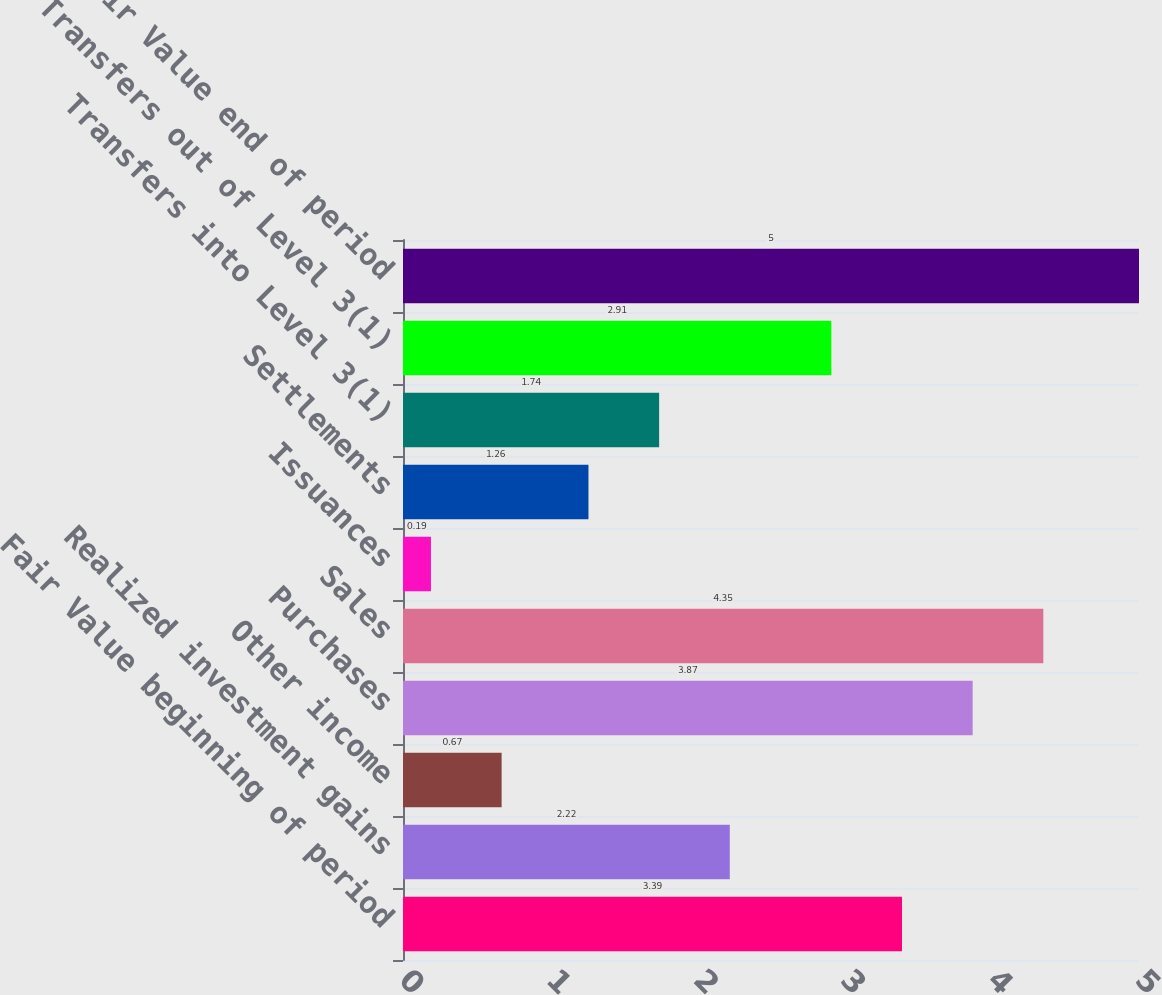<chart> <loc_0><loc_0><loc_500><loc_500><bar_chart><fcel>Fair Value beginning of period<fcel>Realized investment gains<fcel>Other income<fcel>Purchases<fcel>Sales<fcel>Issuances<fcel>Settlements<fcel>Transfers into Level 3(1)<fcel>Transfers out of Level 3(1)<fcel>Fair Value end of period<nl><fcel>3.39<fcel>2.22<fcel>0.67<fcel>3.87<fcel>4.35<fcel>0.19<fcel>1.26<fcel>1.74<fcel>2.91<fcel>5<nl></chart> 